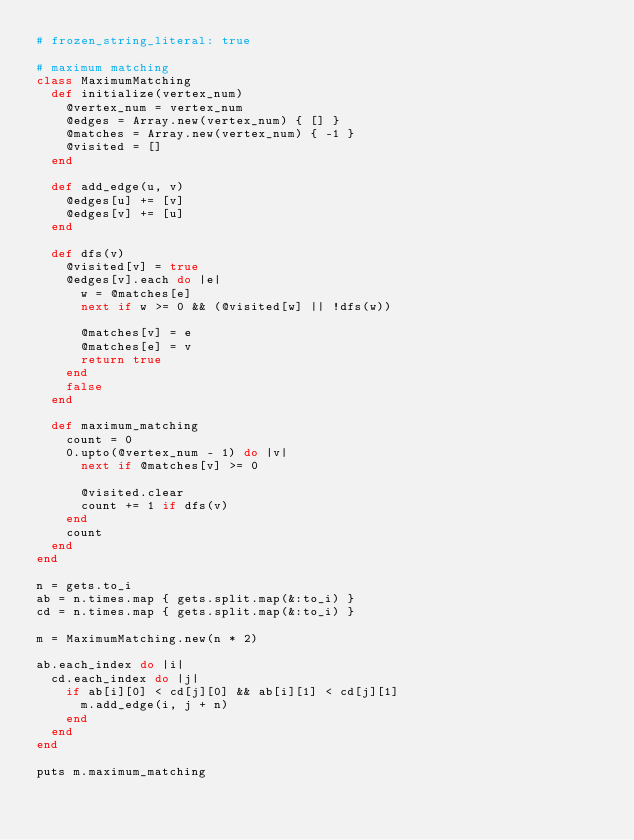Convert code to text. <code><loc_0><loc_0><loc_500><loc_500><_Ruby_># frozen_string_literal: true

# maximum matching
class MaximumMatching
  def initialize(vertex_num)
    @vertex_num = vertex_num
    @edges = Array.new(vertex_num) { [] }
    @matches = Array.new(vertex_num) { -1 }
    @visited = []
  end

  def add_edge(u, v)
    @edges[u] += [v]
    @edges[v] += [u]
  end

  def dfs(v)
    @visited[v] = true
    @edges[v].each do |e|
      w = @matches[e]
      next if w >= 0 && (@visited[w] || !dfs(w))

      @matches[v] = e
      @matches[e] = v
      return true
    end
    false
  end

  def maximum_matching
    count = 0
    0.upto(@vertex_num - 1) do |v|
      next if @matches[v] >= 0

      @visited.clear
      count += 1 if dfs(v)
    end
    count
  end
end

n = gets.to_i
ab = n.times.map { gets.split.map(&:to_i) }
cd = n.times.map { gets.split.map(&:to_i) }

m = MaximumMatching.new(n * 2)

ab.each_index do |i|
  cd.each_index do |j|
    if ab[i][0] < cd[j][0] && ab[i][1] < cd[j][1]
      m.add_edge(i, j + n)
    end
  end
end

puts m.maximum_matching
</code> 